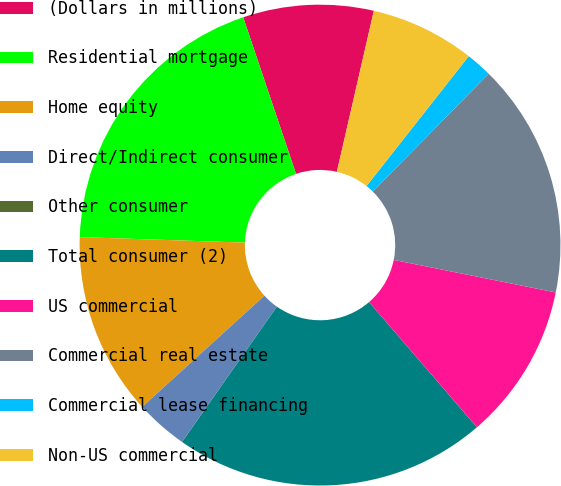Convert chart. <chart><loc_0><loc_0><loc_500><loc_500><pie_chart><fcel>(Dollars in millions)<fcel>Residential mortgage<fcel>Home equity<fcel>Direct/Indirect consumer<fcel>Other consumer<fcel>Total consumer (2)<fcel>US commercial<fcel>Commercial real estate<fcel>Commercial lease financing<fcel>Non-US commercial<nl><fcel>8.77%<fcel>19.29%<fcel>12.28%<fcel>3.51%<fcel>0.01%<fcel>21.04%<fcel>10.53%<fcel>15.78%<fcel>1.76%<fcel>7.02%<nl></chart> 